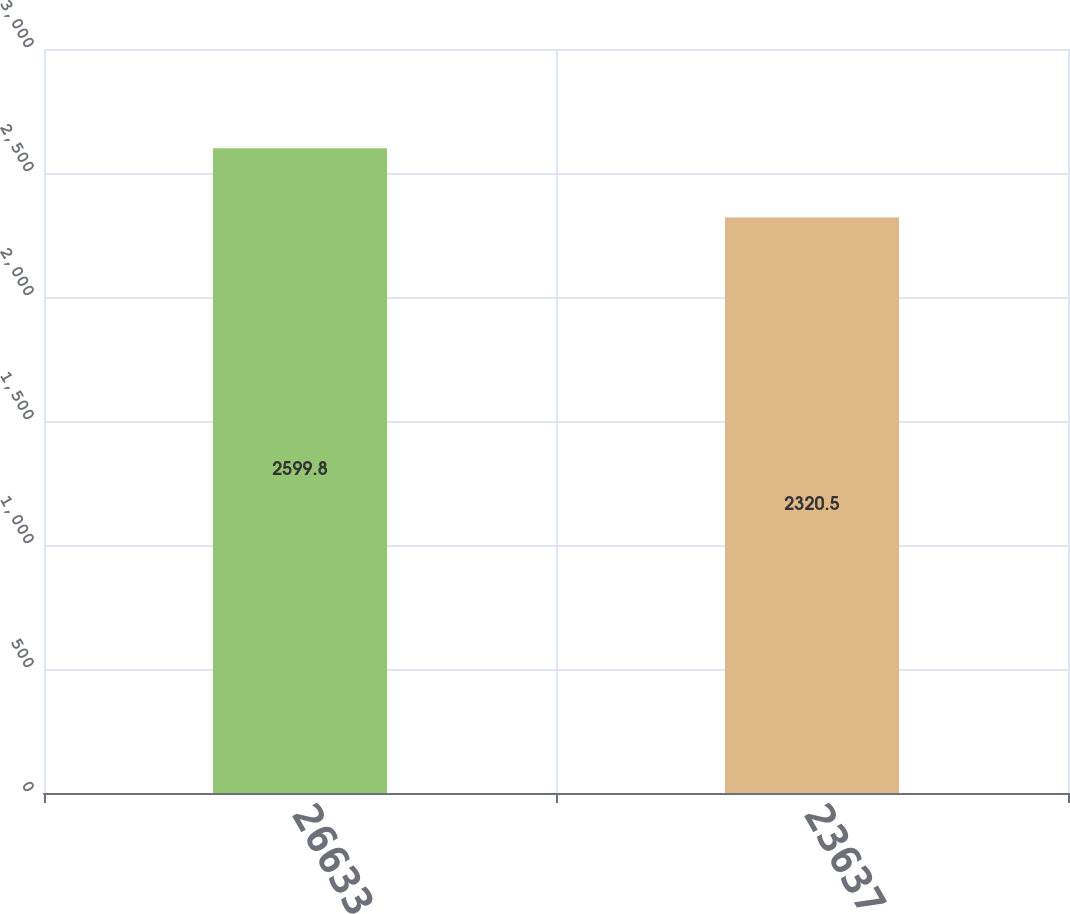Convert chart to OTSL. <chart><loc_0><loc_0><loc_500><loc_500><bar_chart><fcel>26633<fcel>23637<nl><fcel>2599.8<fcel>2320.5<nl></chart> 